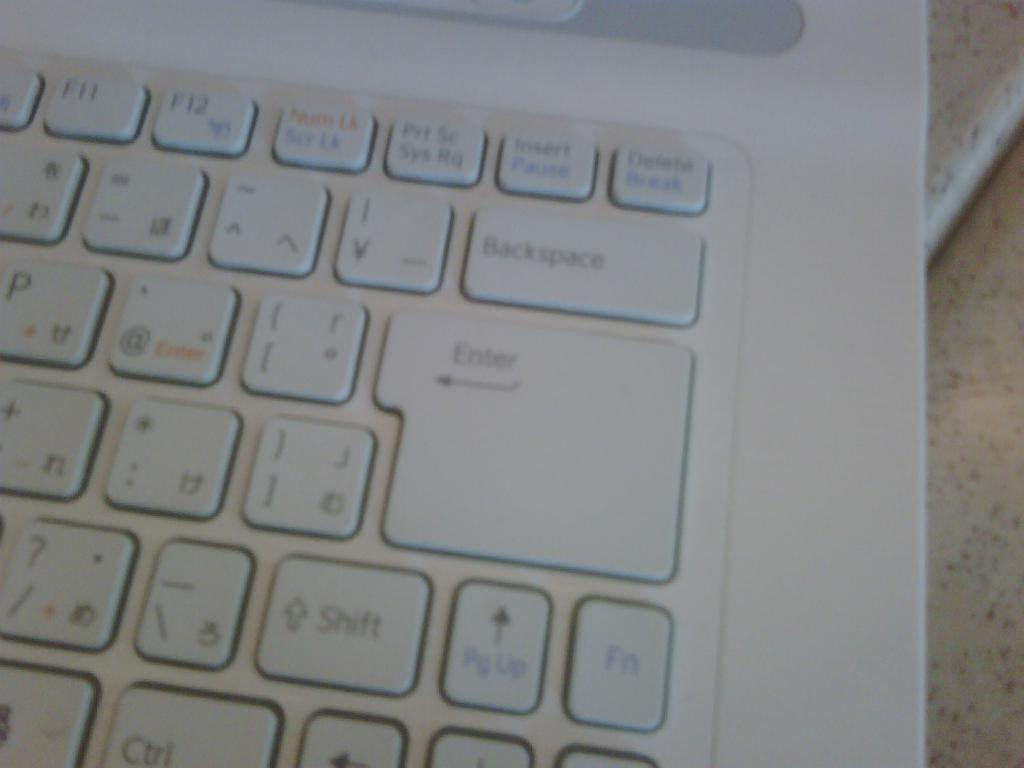<image>
Write a terse but informative summary of the picture. The key labeled Enter is the biggest on the keyboard. 